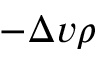Convert formula to latex. <formula><loc_0><loc_0><loc_500><loc_500>- \Delta v \rho</formula> 